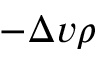Convert formula to latex. <formula><loc_0><loc_0><loc_500><loc_500>- \Delta v \rho</formula> 